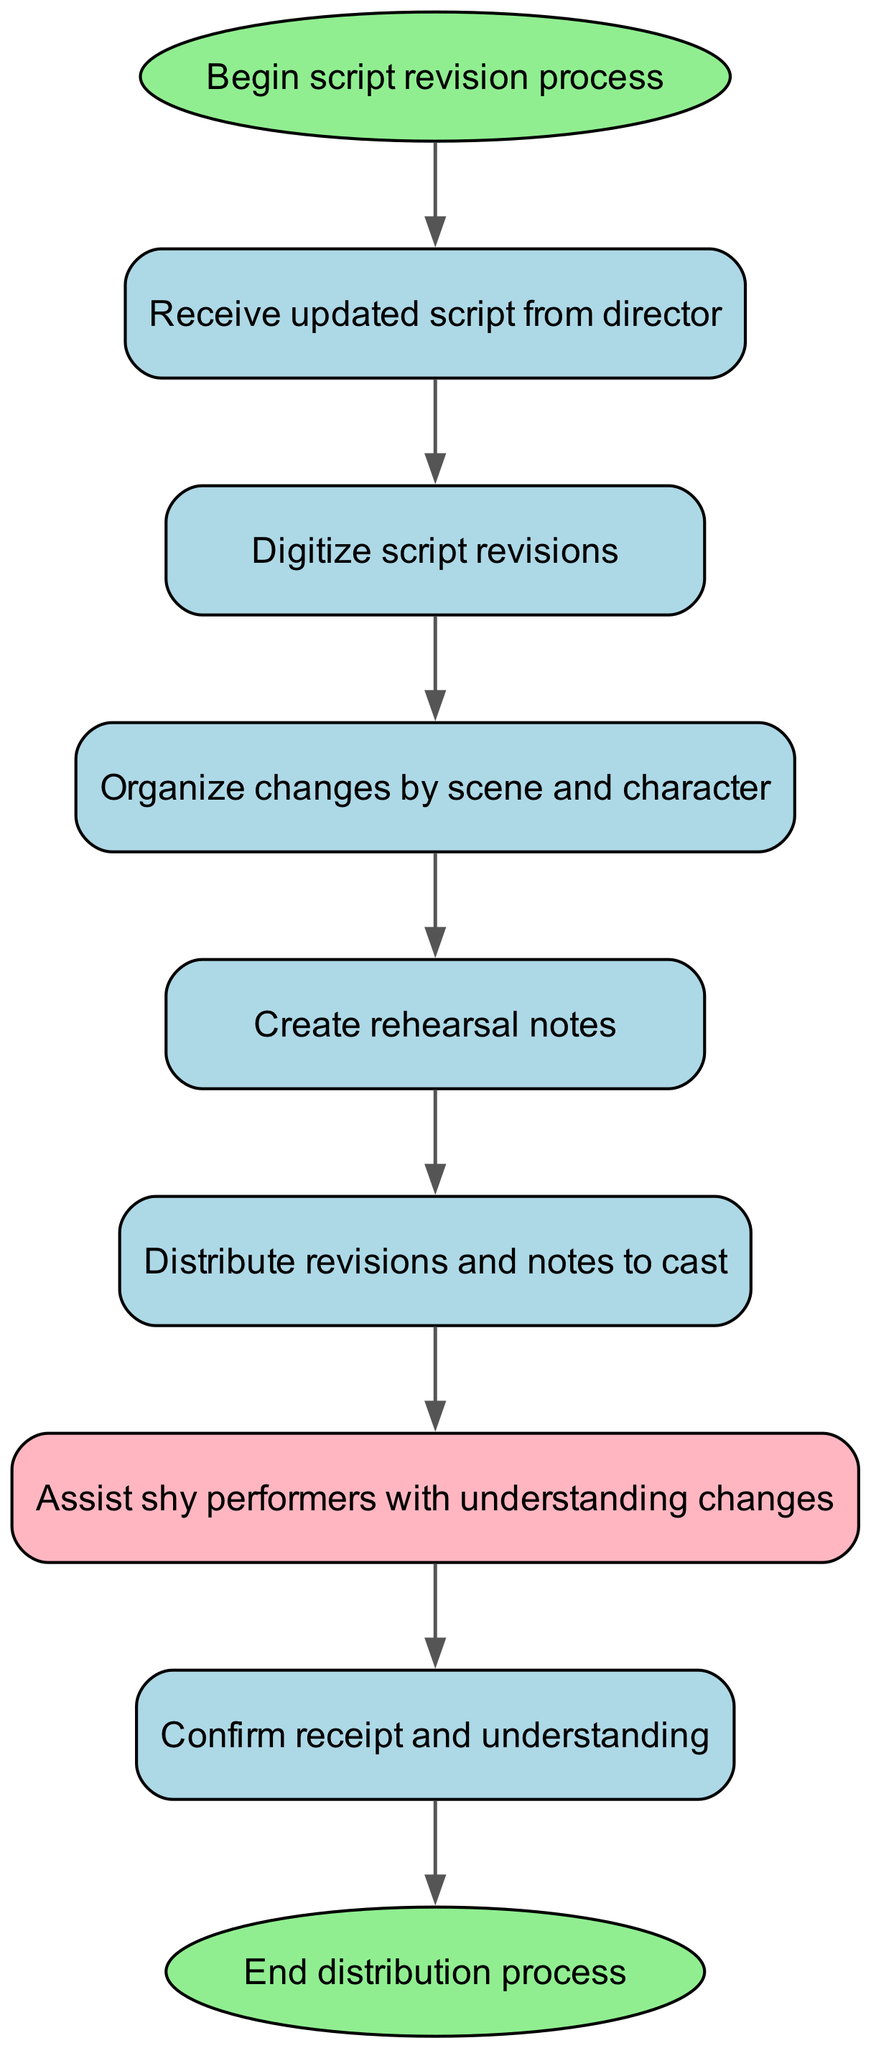What is the starting node in the diagram? The starting node is labeled "Begin script revision process." This is identified by looking at the flowchart's initial point or entry.
Answer: Begin script revision process What comes after receiving the updated script? After the "Receive updated script from director" node, the next node is "Digitize script revisions." This is determined by tracing the flow from the receiving step.
Answer: Digitize script revisions How many nodes are present in the diagram? The diagram contains a total of nine nodes, including start and end points. This is derived by counting each distinct step provided in the nodes list.
Answer: Nine What is the final step in the distribution process? The final step after confirming receipt and understanding is "End distribution process." This can be seen at the last connection point in the flowchart.
Answer: End distribution process Which node assists shy performers? The "Assist shy performers with understanding changes" node is responsible for that role. It can be identified as a special action within the flowchart sequence.
Answer: Assist shy performers with understanding changes What is the relationship between the "distribute" and "assist" nodes? The flow between "distribute" and "assist" indicates that after distributing revisions and notes, assistance is provided to performers. This relationship shows how the two processes are sequential.
Answer: Assist How many edges connect the nodes in the diagram? There are a total of eight edges that connect the nodes based on the specified connections between each step in the flowchart. This is concluded by counting all the directed connections between two nodes.
Answer: Eight What color is assigned to the "assist" node? The "assist" node is filled with a light pink color, specifically described as "#FFB6C1." This can be confirmed by looking at the specific styling applied to that node in the diagram.
Answer: Light pink 